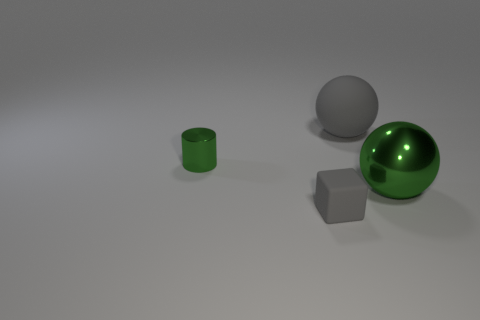Are there any spheres that have the same material as the green cylinder?
Make the answer very short. Yes. There is a green object that is right of the gray rubber thing to the left of the gray object behind the block; what shape is it?
Provide a short and direct response. Sphere. What material is the green cylinder?
Offer a terse response. Metal. What is the color of the tiny thing that is made of the same material as the large gray sphere?
Ensure brevity in your answer.  Gray. Is there a rubber sphere that is behind the green object that is to the right of the gray cube?
Give a very brief answer. Yes. What number of other things are there of the same shape as the tiny gray object?
Ensure brevity in your answer.  0. Is the shape of the gray object that is in front of the metal sphere the same as the large object that is on the left side of the large green metal ball?
Keep it short and to the point. No. How many tiny rubber blocks are to the right of the green shiny thing on the left side of the gray matte thing that is in front of the big green metallic sphere?
Offer a very short reply. 1. The cylinder is what color?
Your response must be concise. Green. How many other things are the same size as the shiny sphere?
Give a very brief answer. 1. 